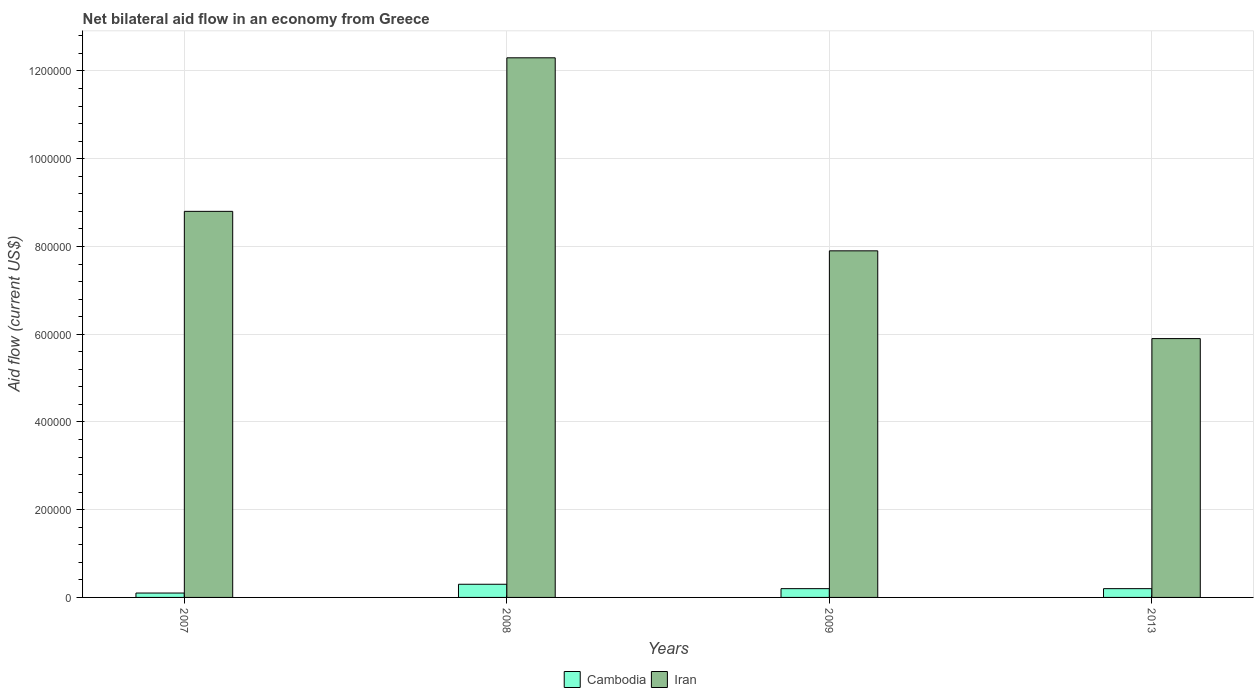How many different coloured bars are there?
Offer a terse response. 2. How many groups of bars are there?
Ensure brevity in your answer.  4. Are the number of bars per tick equal to the number of legend labels?
Give a very brief answer. Yes. Are the number of bars on each tick of the X-axis equal?
Ensure brevity in your answer.  Yes. How many bars are there on the 2nd tick from the left?
Make the answer very short. 2. How many bars are there on the 1st tick from the right?
Offer a very short reply. 2. What is the label of the 1st group of bars from the left?
Give a very brief answer. 2007. In how many cases, is the number of bars for a given year not equal to the number of legend labels?
Your answer should be compact. 0. What is the net bilateral aid flow in Cambodia in 2013?
Your answer should be very brief. 2.00e+04. Across all years, what is the maximum net bilateral aid flow in Iran?
Your response must be concise. 1.23e+06. What is the difference between the net bilateral aid flow in Iran in 2009 and that in 2013?
Your answer should be compact. 2.00e+05. What is the difference between the net bilateral aid flow in Cambodia in 2007 and the net bilateral aid flow in Iran in 2008?
Make the answer very short. -1.22e+06. In the year 2008, what is the difference between the net bilateral aid flow in Iran and net bilateral aid flow in Cambodia?
Offer a very short reply. 1.20e+06. What is the ratio of the net bilateral aid flow in Iran in 2009 to that in 2013?
Ensure brevity in your answer.  1.34. Is the difference between the net bilateral aid flow in Iran in 2008 and 2013 greater than the difference between the net bilateral aid flow in Cambodia in 2008 and 2013?
Your answer should be very brief. Yes. Is the sum of the net bilateral aid flow in Cambodia in 2007 and 2008 greater than the maximum net bilateral aid flow in Iran across all years?
Keep it short and to the point. No. What does the 2nd bar from the left in 2013 represents?
Provide a succinct answer. Iran. What does the 2nd bar from the right in 2008 represents?
Your answer should be compact. Cambodia. How many bars are there?
Provide a short and direct response. 8. Does the graph contain any zero values?
Your answer should be compact. No. Does the graph contain grids?
Offer a terse response. Yes. What is the title of the graph?
Offer a very short reply. Net bilateral aid flow in an economy from Greece. Does "Ukraine" appear as one of the legend labels in the graph?
Your answer should be compact. No. What is the label or title of the Y-axis?
Your answer should be very brief. Aid flow (current US$). What is the Aid flow (current US$) in Cambodia in 2007?
Provide a short and direct response. 10000. What is the Aid flow (current US$) of Iran in 2007?
Offer a terse response. 8.80e+05. What is the Aid flow (current US$) of Cambodia in 2008?
Your answer should be very brief. 3.00e+04. What is the Aid flow (current US$) in Iran in 2008?
Ensure brevity in your answer.  1.23e+06. What is the Aid flow (current US$) in Iran in 2009?
Ensure brevity in your answer.  7.90e+05. What is the Aid flow (current US$) in Iran in 2013?
Offer a very short reply. 5.90e+05. Across all years, what is the maximum Aid flow (current US$) in Cambodia?
Offer a very short reply. 3.00e+04. Across all years, what is the maximum Aid flow (current US$) of Iran?
Offer a very short reply. 1.23e+06. Across all years, what is the minimum Aid flow (current US$) in Iran?
Ensure brevity in your answer.  5.90e+05. What is the total Aid flow (current US$) in Cambodia in the graph?
Your answer should be compact. 8.00e+04. What is the total Aid flow (current US$) in Iran in the graph?
Offer a very short reply. 3.49e+06. What is the difference between the Aid flow (current US$) in Iran in 2007 and that in 2008?
Offer a terse response. -3.50e+05. What is the difference between the Aid flow (current US$) in Iran in 2007 and that in 2009?
Your answer should be very brief. 9.00e+04. What is the difference between the Aid flow (current US$) of Iran in 2007 and that in 2013?
Offer a very short reply. 2.90e+05. What is the difference between the Aid flow (current US$) of Iran in 2008 and that in 2009?
Make the answer very short. 4.40e+05. What is the difference between the Aid flow (current US$) in Cambodia in 2008 and that in 2013?
Offer a very short reply. 10000. What is the difference between the Aid flow (current US$) of Iran in 2008 and that in 2013?
Ensure brevity in your answer.  6.40e+05. What is the difference between the Aid flow (current US$) in Iran in 2009 and that in 2013?
Give a very brief answer. 2.00e+05. What is the difference between the Aid flow (current US$) in Cambodia in 2007 and the Aid flow (current US$) in Iran in 2008?
Your response must be concise. -1.22e+06. What is the difference between the Aid flow (current US$) in Cambodia in 2007 and the Aid flow (current US$) in Iran in 2009?
Your answer should be compact. -7.80e+05. What is the difference between the Aid flow (current US$) in Cambodia in 2007 and the Aid flow (current US$) in Iran in 2013?
Your response must be concise. -5.80e+05. What is the difference between the Aid flow (current US$) in Cambodia in 2008 and the Aid flow (current US$) in Iran in 2009?
Offer a terse response. -7.60e+05. What is the difference between the Aid flow (current US$) of Cambodia in 2008 and the Aid flow (current US$) of Iran in 2013?
Make the answer very short. -5.60e+05. What is the difference between the Aid flow (current US$) in Cambodia in 2009 and the Aid flow (current US$) in Iran in 2013?
Provide a succinct answer. -5.70e+05. What is the average Aid flow (current US$) of Cambodia per year?
Your answer should be compact. 2.00e+04. What is the average Aid flow (current US$) in Iran per year?
Offer a very short reply. 8.72e+05. In the year 2007, what is the difference between the Aid flow (current US$) of Cambodia and Aid flow (current US$) of Iran?
Keep it short and to the point. -8.70e+05. In the year 2008, what is the difference between the Aid flow (current US$) of Cambodia and Aid flow (current US$) of Iran?
Give a very brief answer. -1.20e+06. In the year 2009, what is the difference between the Aid flow (current US$) in Cambodia and Aid flow (current US$) in Iran?
Make the answer very short. -7.70e+05. In the year 2013, what is the difference between the Aid flow (current US$) in Cambodia and Aid flow (current US$) in Iran?
Provide a succinct answer. -5.70e+05. What is the ratio of the Aid flow (current US$) in Cambodia in 2007 to that in 2008?
Your answer should be compact. 0.33. What is the ratio of the Aid flow (current US$) of Iran in 2007 to that in 2008?
Provide a succinct answer. 0.72. What is the ratio of the Aid flow (current US$) of Cambodia in 2007 to that in 2009?
Make the answer very short. 0.5. What is the ratio of the Aid flow (current US$) of Iran in 2007 to that in 2009?
Ensure brevity in your answer.  1.11. What is the ratio of the Aid flow (current US$) in Cambodia in 2007 to that in 2013?
Ensure brevity in your answer.  0.5. What is the ratio of the Aid flow (current US$) in Iran in 2007 to that in 2013?
Ensure brevity in your answer.  1.49. What is the ratio of the Aid flow (current US$) of Iran in 2008 to that in 2009?
Provide a short and direct response. 1.56. What is the ratio of the Aid flow (current US$) of Iran in 2008 to that in 2013?
Keep it short and to the point. 2.08. What is the ratio of the Aid flow (current US$) of Iran in 2009 to that in 2013?
Your answer should be compact. 1.34. What is the difference between the highest and the second highest Aid flow (current US$) in Iran?
Offer a very short reply. 3.50e+05. What is the difference between the highest and the lowest Aid flow (current US$) of Iran?
Your response must be concise. 6.40e+05. 